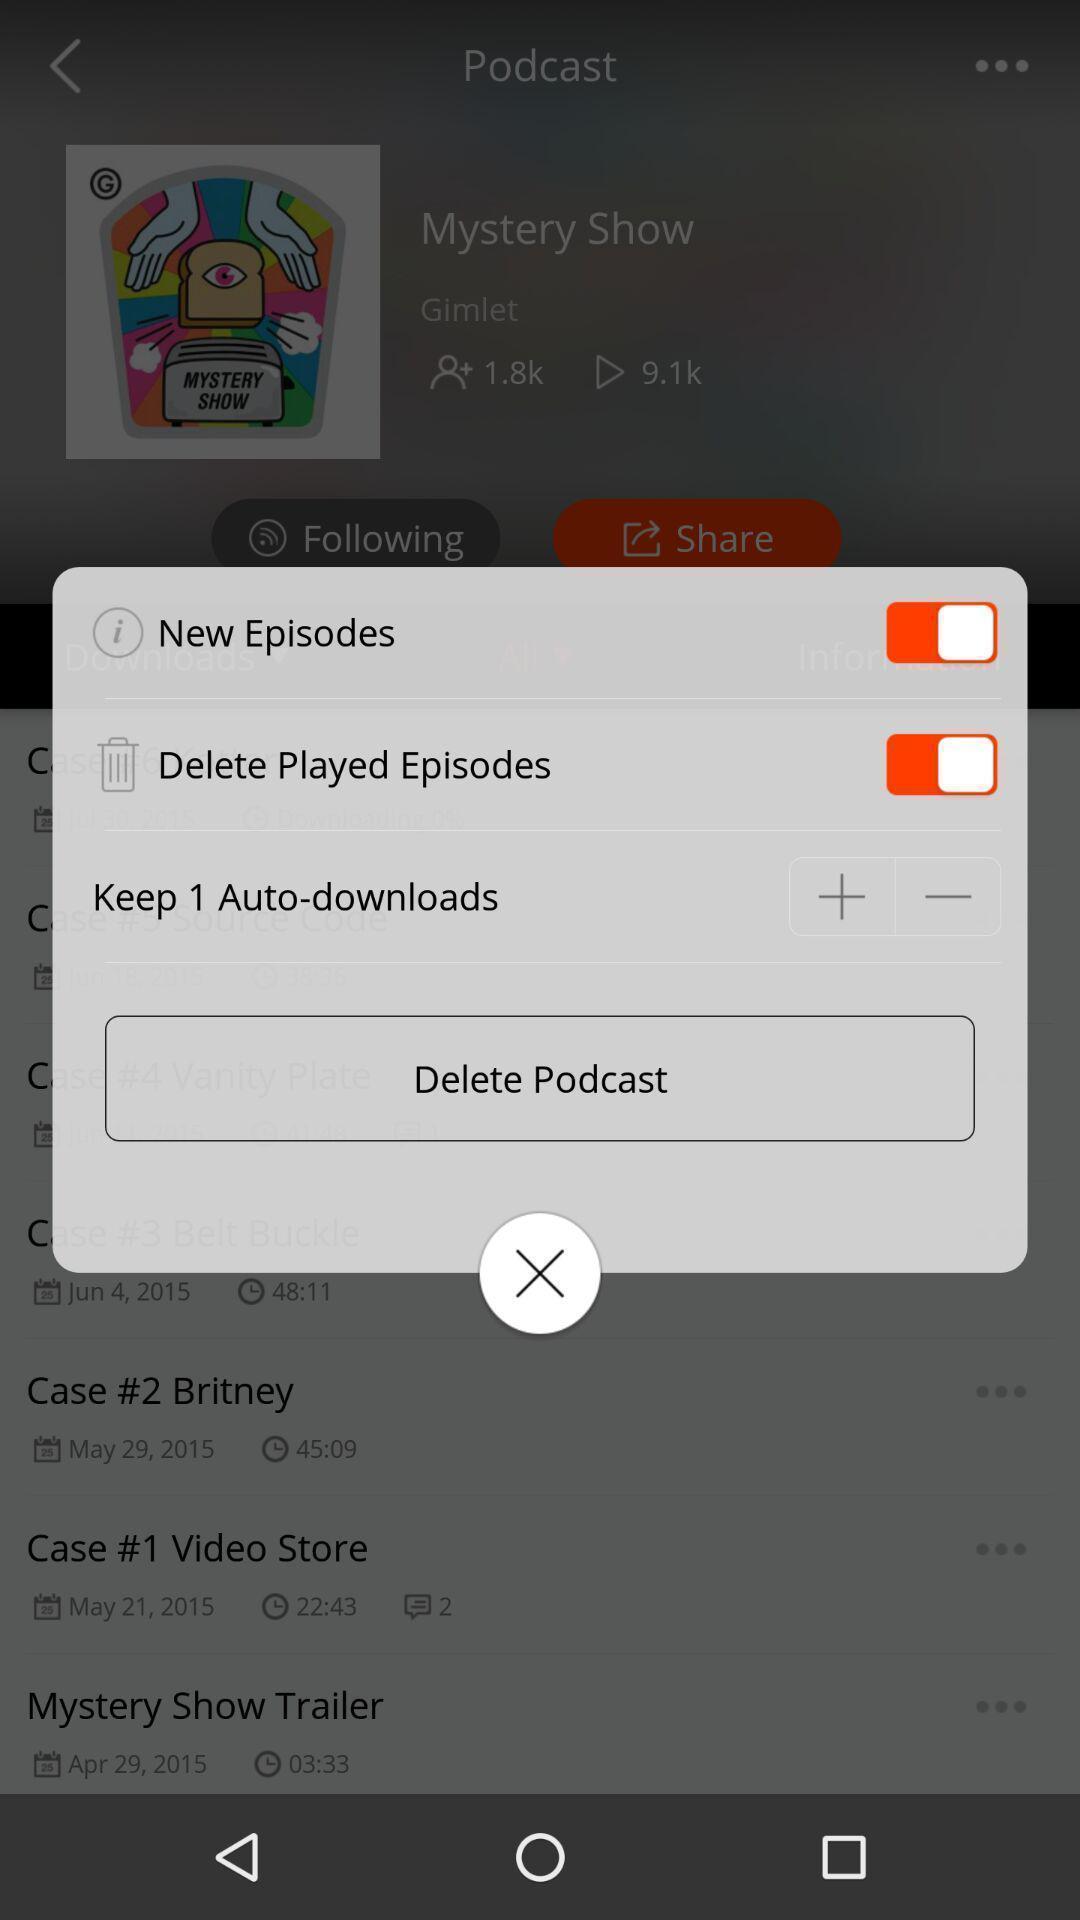Describe the visual elements of this screenshot. Pop-up displaying different options with enable option. 